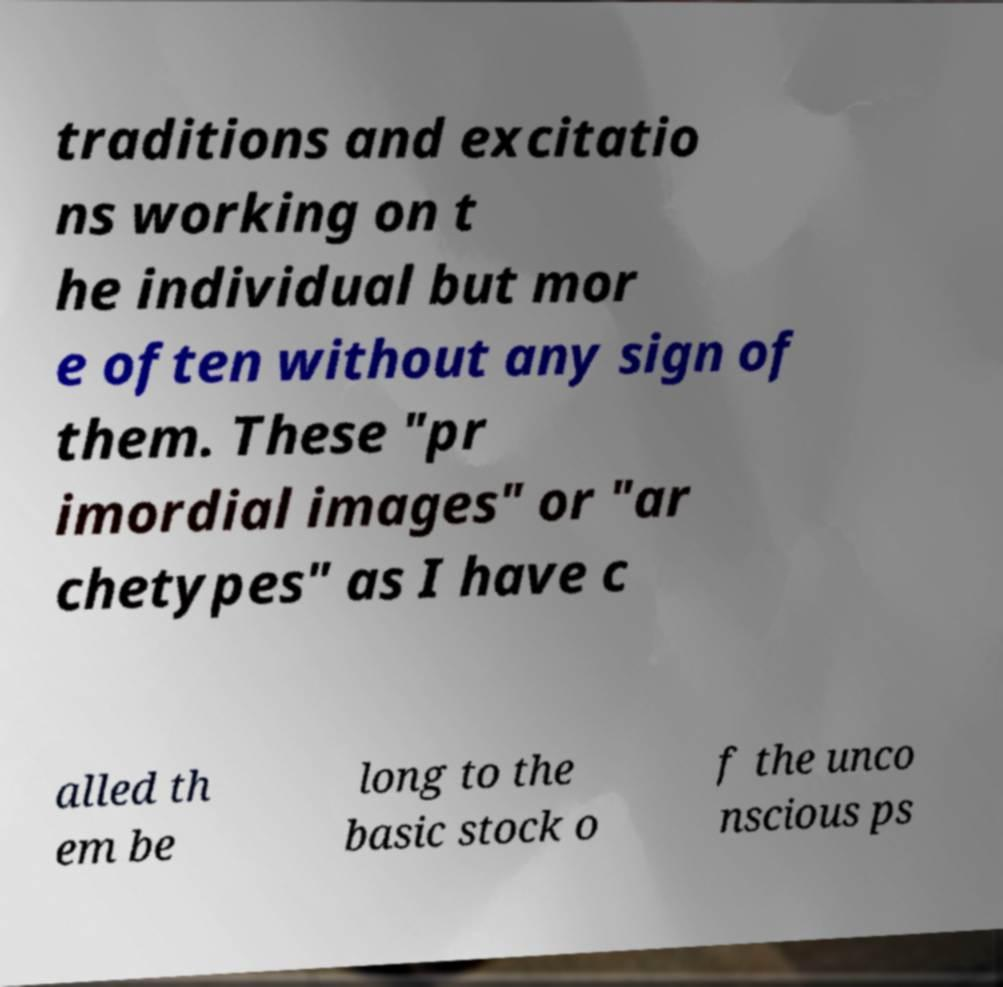Can you accurately transcribe the text from the provided image for me? traditions and excitatio ns working on t he individual but mor e often without any sign of them. These "pr imordial images" or "ar chetypes" as I have c alled th em be long to the basic stock o f the unco nscious ps 